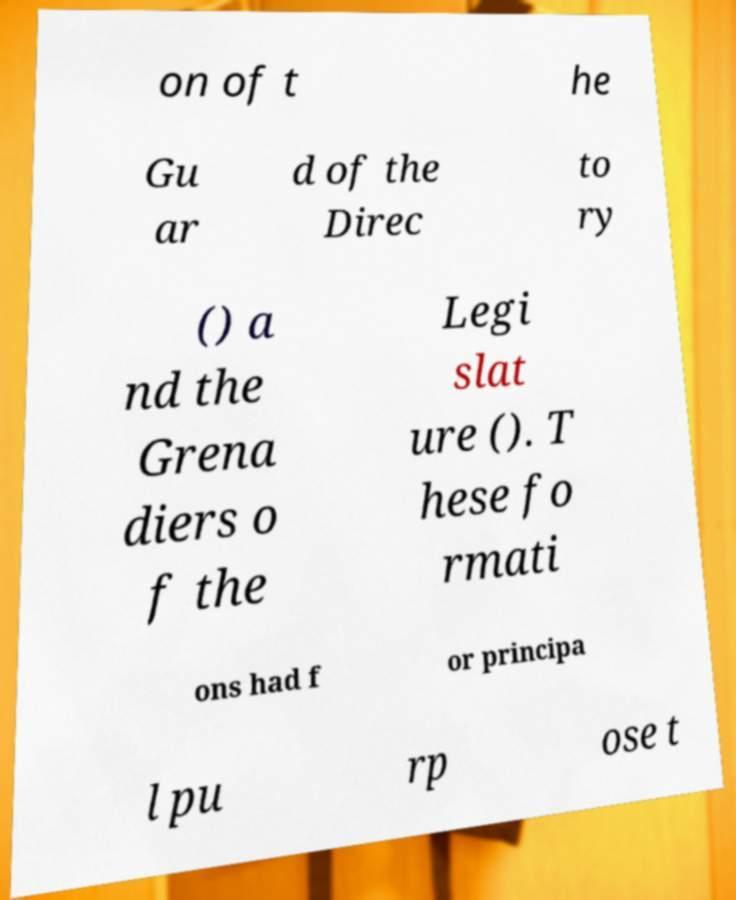Can you read and provide the text displayed in the image?This photo seems to have some interesting text. Can you extract and type it out for me? on of t he Gu ar d of the Direc to ry () a nd the Grena diers o f the Legi slat ure (). T hese fo rmati ons had f or principa l pu rp ose t 